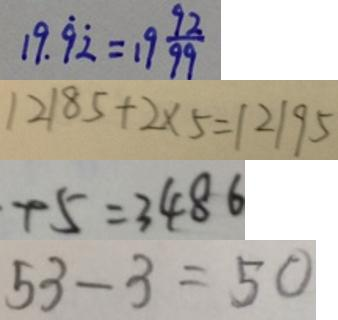Convert formula to latex. <formula><loc_0><loc_0><loc_500><loc_500>1 9 . \dot { 9 } \dot { 2 } = 1 9 \frac { 9 2 } { 9 9 } 
 1 2 1 8 5 + 2 \times 5 = 1 2 1 9 5 
 + 5 = 3 4 8 6 
 5 3 - 3 = 5 0</formula> 